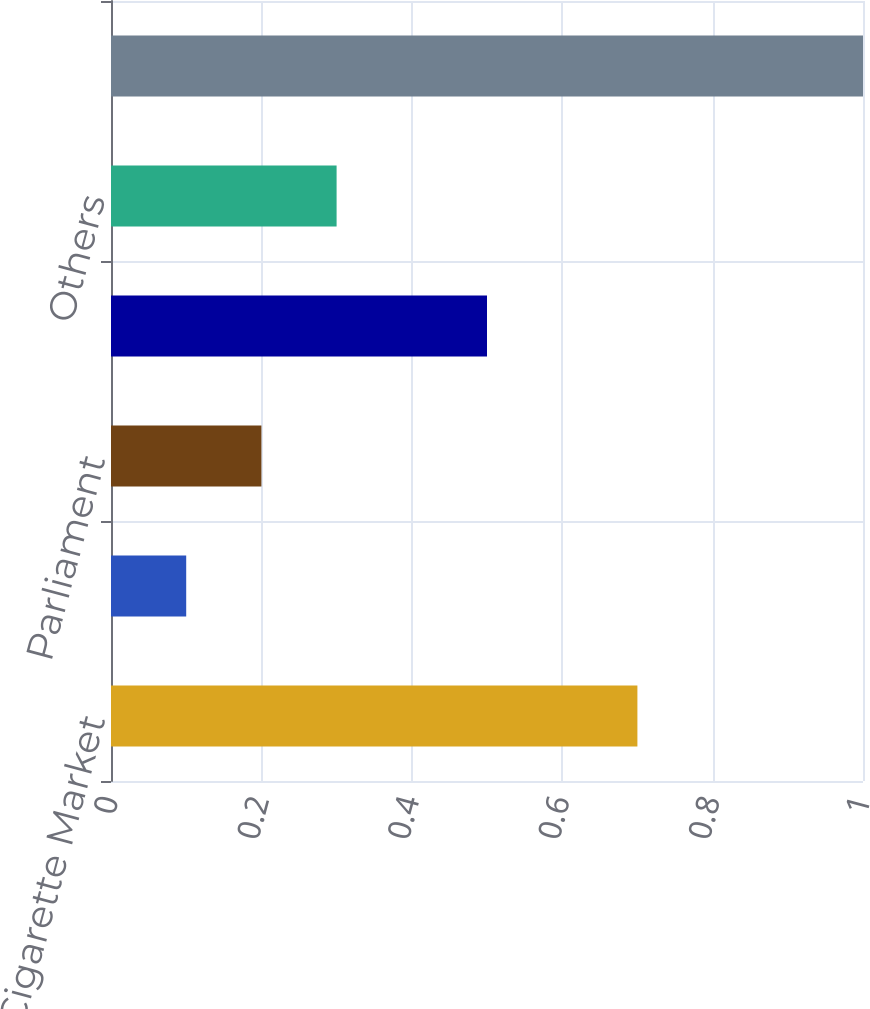Convert chart. <chart><loc_0><loc_0><loc_500><loc_500><bar_chart><fcel>Total Cigarette Market<fcel>PMI Cigarette Shipments<fcel>Parliament<fcel>Lark<fcel>Others<fcel>Total<nl><fcel>0.7<fcel>0.1<fcel>0.2<fcel>0.5<fcel>0.3<fcel>1<nl></chart> 